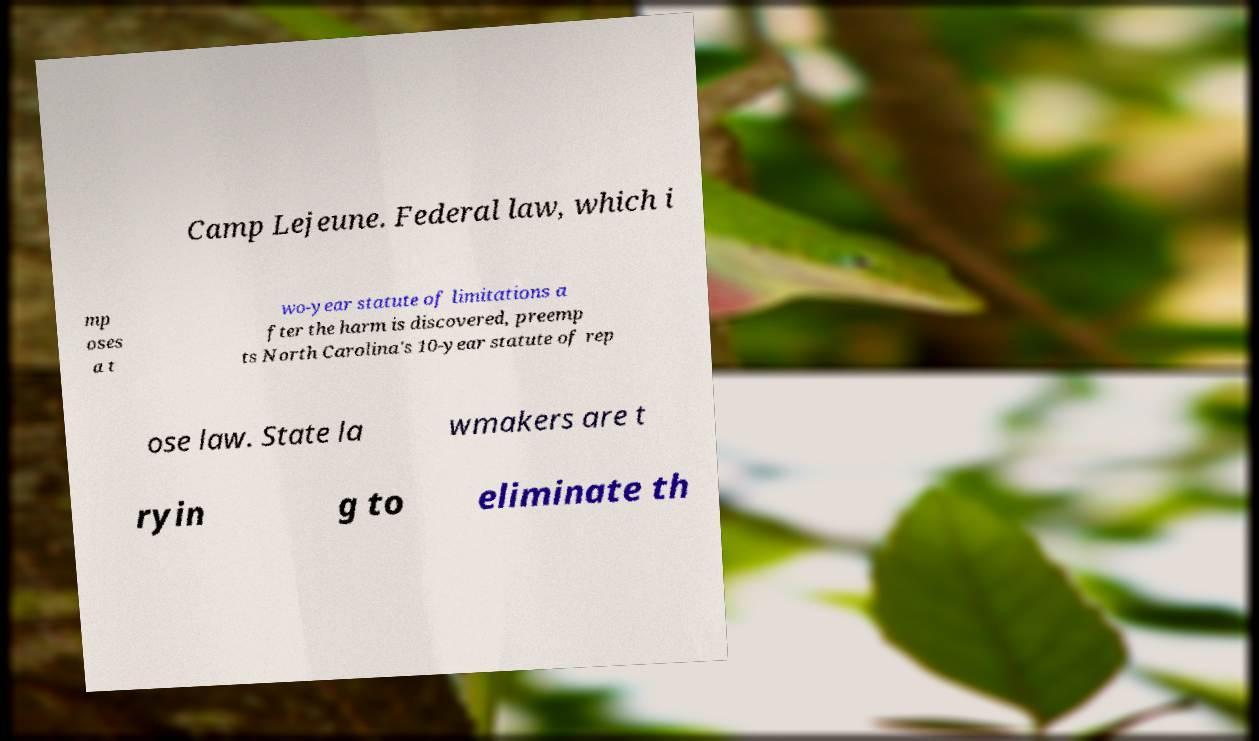Could you assist in decoding the text presented in this image and type it out clearly? Camp Lejeune. Federal law, which i mp oses a t wo-year statute of limitations a fter the harm is discovered, preemp ts North Carolina's 10-year statute of rep ose law. State la wmakers are t ryin g to eliminate th 